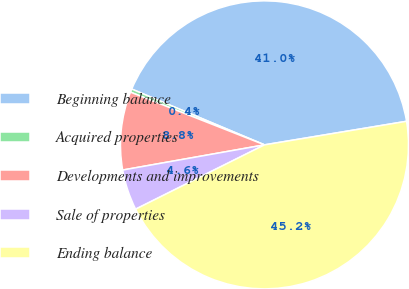Convert chart to OTSL. <chart><loc_0><loc_0><loc_500><loc_500><pie_chart><fcel>Beginning balance<fcel>Acquired properties<fcel>Developments and improvements<fcel>Sale of properties<fcel>Ending balance<nl><fcel>41.05%<fcel>0.37%<fcel>8.76%<fcel>4.57%<fcel>45.25%<nl></chart> 